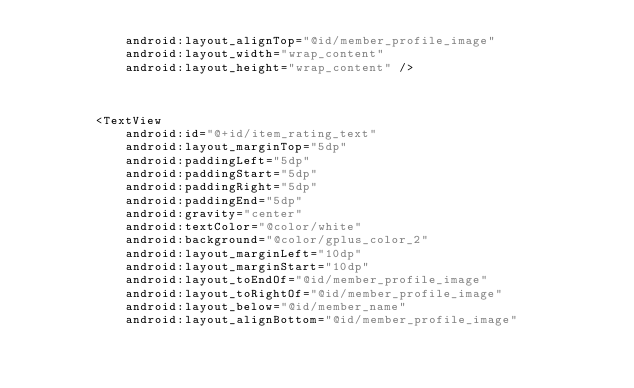<code> <loc_0><loc_0><loc_500><loc_500><_XML_>            android:layout_alignTop="@id/member_profile_image"
            android:layout_width="wrap_content"
            android:layout_height="wrap_content" />



        <TextView
            android:id="@+id/item_rating_text"
            android:layout_marginTop="5dp"
            android:paddingLeft="5dp"
            android:paddingStart="5dp"
            android:paddingRight="5dp"
            android:paddingEnd="5dp"
            android:gravity="center"
            android:textColor="@color/white"
            android:background="@color/gplus_color_2"
            android:layout_marginLeft="10dp"
            android:layout_marginStart="10dp"
            android:layout_toEndOf="@id/member_profile_image"
            android:layout_toRightOf="@id/member_profile_image"
            android:layout_below="@id/member_name"
            android:layout_alignBottom="@id/member_profile_image"</code> 